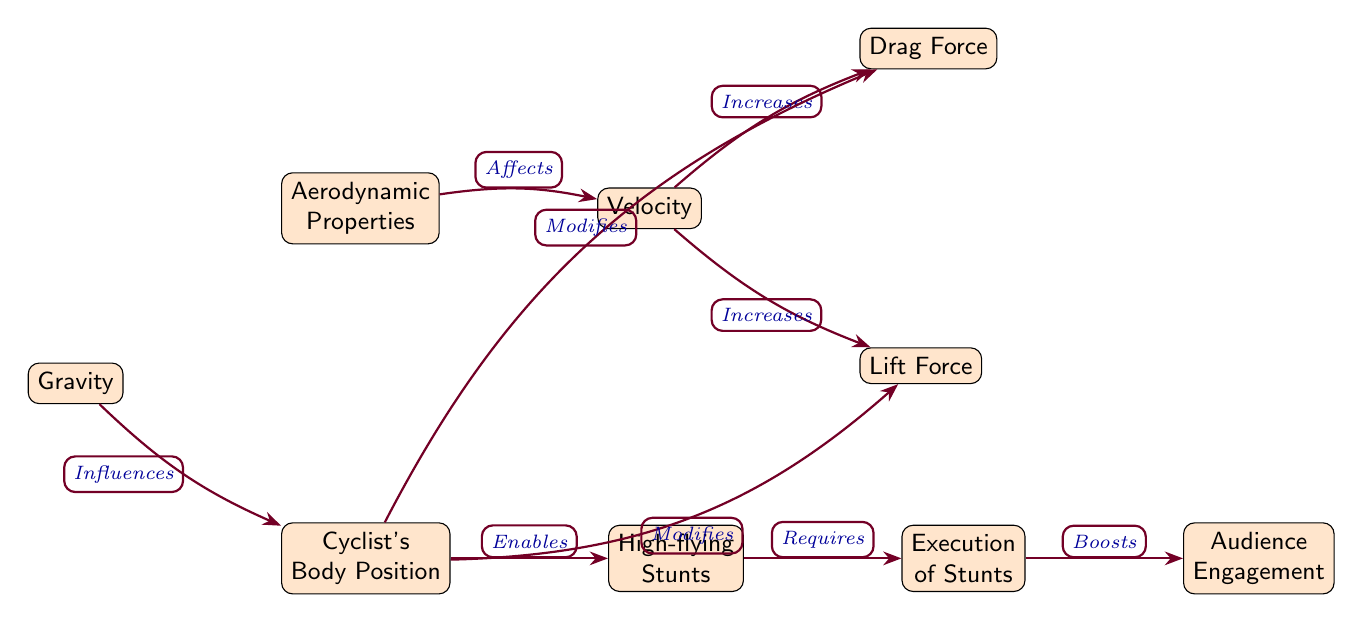What is the primary focus of the diagram? The primary focus of the diagram is to illustrate the aerodynamic properties and physics behind high-flying stunts in extreme sports, visualized through flow diagrams and influence maps.
Answer: Aerodynamics and Physics How many main nodes are present in the diagram? By counting all the distinct labeled nodes in the diagram, there are a total of six main nodes represented.
Answer: 6 Which node is directly affected by aerodynamic properties? The node that is directly affected by aerodynamic properties is the "Velocity" node, which is connected by an arrow indicating influence.
Answer: Velocity What relationship does "Velocity" have with "Drag Force"? The relationship shows that an increase in velocity results in an increase in drag force, as indicated by the directional arrow between these two nodes.
Answer: Increases What influences the "Cyclist's Body Position"? The "Gravity" node influences the "Cyclist's Body Position," as shown by the connection indicated by an arrow, which suggests a direct relationship.
Answer: Gravity Which node is modified by "Cyclist's Body Position"? The "Drag Force" node is one of the nodes modified by the "Cyclist's Body Position," as indicated by a directional arrow showing this modification.
Answer: Drag Force What is required for the execution of stunts? In the diagram, the execution of stunts requires input from the "High-flying Stunts" node, which is connected directly to it by a labeled arrow.
Answer: High-flying Stunts How does "Execution of Stunts" affect "Audience Engagement"? The "Execution of Stunts" boosts "Audience Engagement," as shown by the directional relationship from the execution node to the engagement node.
Answer: Boosts What modifies both "Drag Force" and "Lift Force"? The "Cyclist's Body Position" node modifies both "Drag Force" and "Lift Force," indicating it has a dual impact on these aerodynamic factors.
Answer: Cyclist's Body Position What type of diagram is used to represent the interactions in this context? The diagram is a flow diagram, which represents directional relationships and influences among several variables related to aerodynamics and extreme sports.
Answer: Flow Diagram 